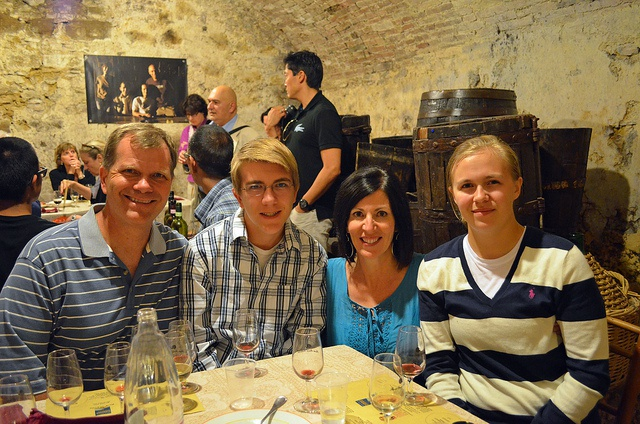Describe the objects in this image and their specific colors. I can see people in olive, black, tan, khaki, and brown tones, people in olive, black, gray, brown, and darkgray tones, people in olive, black, gray, brown, and tan tones, dining table in olive, khaki, and tan tones, and people in olive, black, brown, teal, and blue tones in this image. 